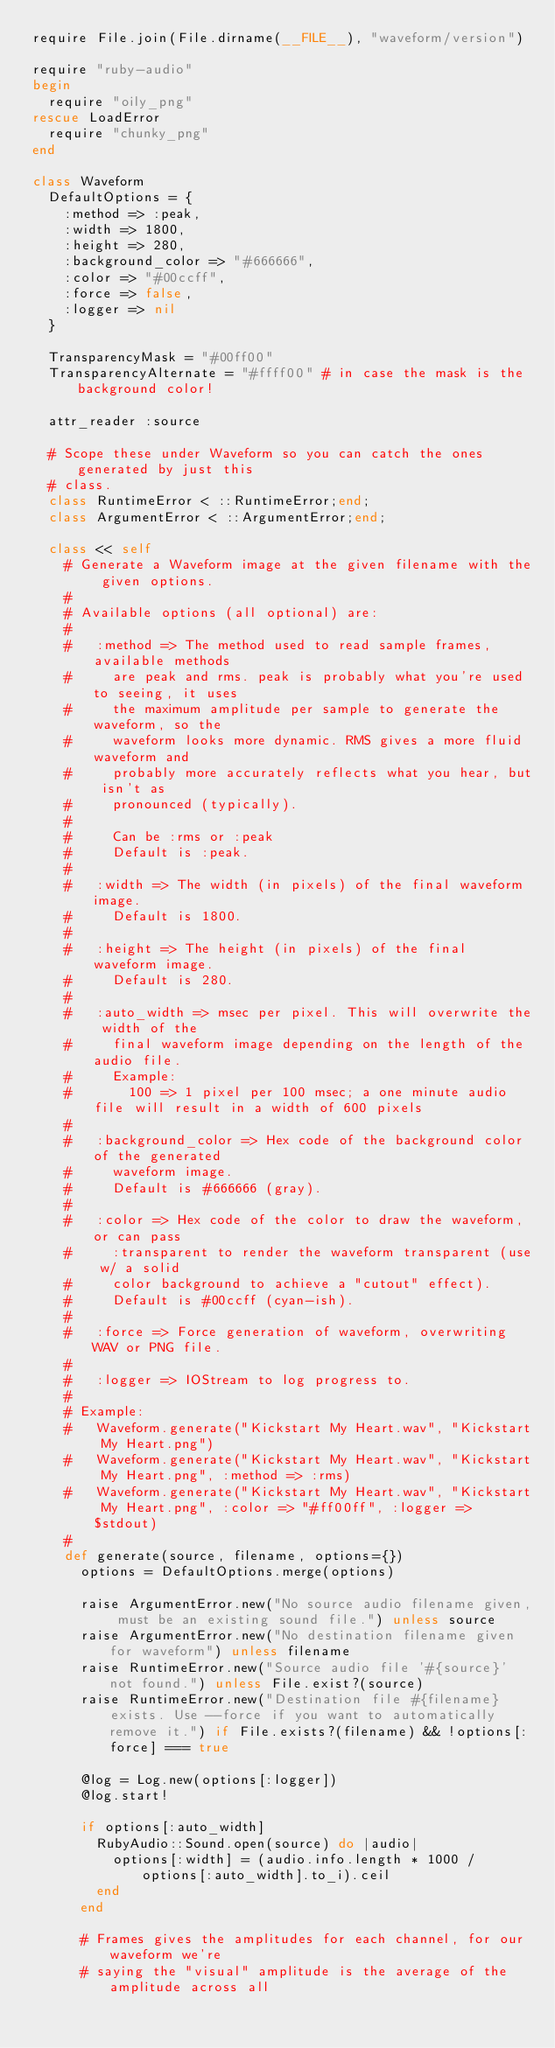<code> <loc_0><loc_0><loc_500><loc_500><_Ruby_>require File.join(File.dirname(__FILE__), "waveform/version")

require "ruby-audio"
begin
  require "oily_png"
rescue LoadError
  require "chunky_png"
end

class Waveform
  DefaultOptions = {
    :method => :peak,
    :width => 1800,
    :height => 280,
    :background_color => "#666666",
    :color => "#00ccff",
    :force => false,
    :logger => nil
  }

  TransparencyMask = "#00ff00"
  TransparencyAlternate = "#ffff00" # in case the mask is the background color!

  attr_reader :source

  # Scope these under Waveform so you can catch the ones generated by just this
  # class.
  class RuntimeError < ::RuntimeError;end;
  class ArgumentError < ::ArgumentError;end;

  class << self
    # Generate a Waveform image at the given filename with the given options.
    #
    # Available options (all optional) are:
    #
    #   :method => The method used to read sample frames, available methods
    #     are peak and rms. peak is probably what you're used to seeing, it uses
    #     the maximum amplitude per sample to generate the waveform, so the
    #     waveform looks more dynamic. RMS gives a more fluid waveform and
    #     probably more accurately reflects what you hear, but isn't as
    #     pronounced (typically).
    #
    #     Can be :rms or :peak
    #     Default is :peak.
    #
    #   :width => The width (in pixels) of the final waveform image.
    #     Default is 1800.
    #
    #   :height => The height (in pixels) of the final waveform image.
    #     Default is 280.
    #
    #   :auto_width => msec per pixel. This will overwrite the width of the
    #     final waveform image depending on the length of the audio file.
    #     Example:
    #       100 => 1 pixel per 100 msec; a one minute audio file will result in a width of 600 pixels
    #
    #   :background_color => Hex code of the background color of the generated
    #     waveform image.
    #     Default is #666666 (gray).
    #
    #   :color => Hex code of the color to draw the waveform, or can pass
    #     :transparent to render the waveform transparent (use w/ a solid
    #     color background to achieve a "cutout" effect).
    #     Default is #00ccff (cyan-ish).
    #
    #   :force => Force generation of waveform, overwriting WAV or PNG file.
    #
    #   :logger => IOStream to log progress to.
    #
    # Example:
    #   Waveform.generate("Kickstart My Heart.wav", "Kickstart My Heart.png")
    #   Waveform.generate("Kickstart My Heart.wav", "Kickstart My Heart.png", :method => :rms)
    #   Waveform.generate("Kickstart My Heart.wav", "Kickstart My Heart.png", :color => "#ff00ff", :logger => $stdout)
    #
    def generate(source, filename, options={})
      options = DefaultOptions.merge(options)

      raise ArgumentError.new("No source audio filename given, must be an existing sound file.") unless source
      raise ArgumentError.new("No destination filename given for waveform") unless filename
      raise RuntimeError.new("Source audio file '#{source}' not found.") unless File.exist?(source)
      raise RuntimeError.new("Destination file #{filename} exists. Use --force if you want to automatically remove it.") if File.exists?(filename) && !options[:force] === true

      @log = Log.new(options[:logger])
      @log.start!

      if options[:auto_width]
        RubyAudio::Sound.open(source) do |audio|
          options[:width] = (audio.info.length * 1000 / options[:auto_width].to_i).ceil
        end
      end

      # Frames gives the amplitudes for each channel, for our waveform we're
      # saying the "visual" amplitude is the average of the amplitude across all</code> 